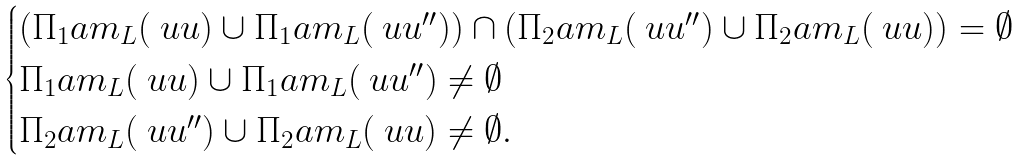<formula> <loc_0><loc_0><loc_500><loc_500>\begin{cases} \left ( \Pi _ { 1 } \L a m _ { L } ( \ u u ) \cup \Pi _ { 1 } \L a m _ { L } ( \ u u ^ { \prime \prime } ) \right ) \cap \left ( \Pi _ { 2 } \L a m _ { L } ( \ u u ^ { \prime \prime } ) \cup \Pi _ { 2 } \L a m _ { L } ( \ u u ) \right ) = \emptyset \\ \Pi _ { 1 } \L a m _ { L } ( \ u u ) \cup \Pi _ { 1 } \L a m _ { L } ( \ u u ^ { \prime \prime } ) \neq \emptyset \\ \Pi _ { 2 } \L a m _ { L } ( \ u u ^ { \prime \prime } ) \cup \Pi _ { 2 } \L a m _ { L } ( \ u u ) \neq \emptyset . \end{cases}</formula> 